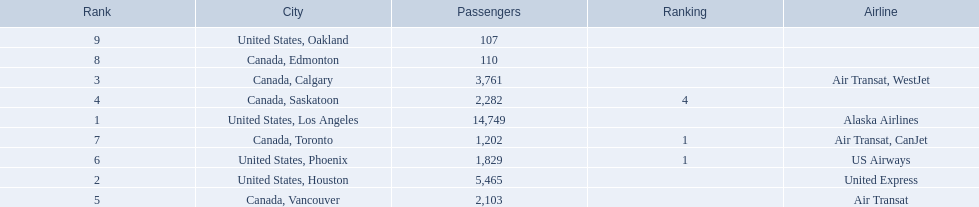Which airport has the least amount of passengers? 107. What airport has 107 passengers? United States, Oakland. 